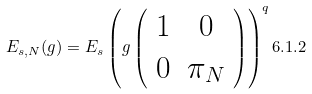Convert formula to latex. <formula><loc_0><loc_0><loc_500><loc_500>E _ { s , N } ( g ) = E _ { s } \left ( g \left ( \begin{array} { c c } 1 & 0 \\ 0 & \pi _ { N } \end{array} \right ) \right ) ^ { q } { 6 . 1 . 2 }</formula> 